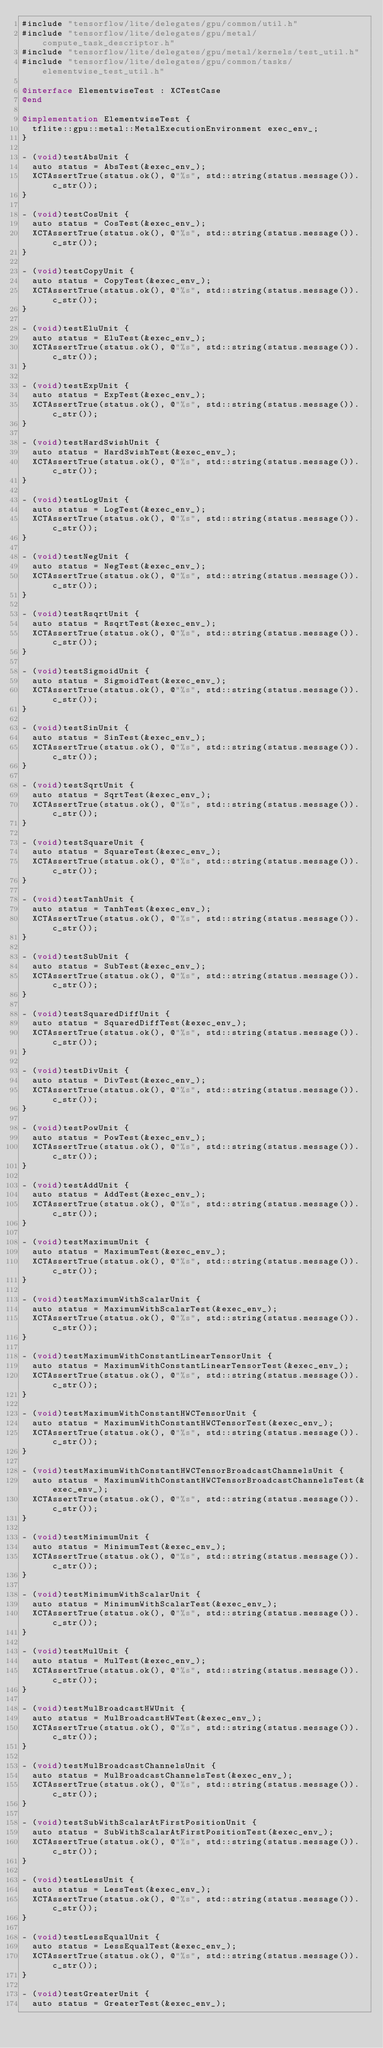<code> <loc_0><loc_0><loc_500><loc_500><_ObjectiveC_>#include "tensorflow/lite/delegates/gpu/common/util.h"
#include "tensorflow/lite/delegates/gpu/metal/compute_task_descriptor.h"
#include "tensorflow/lite/delegates/gpu/metal/kernels/test_util.h"
#include "tensorflow/lite/delegates/gpu/common/tasks/elementwise_test_util.h"

@interface ElementwiseTest : XCTestCase
@end

@implementation ElementwiseTest {
  tflite::gpu::metal::MetalExecutionEnvironment exec_env_;
}

- (void)testAbsUnit {
  auto status = AbsTest(&exec_env_);
  XCTAssertTrue(status.ok(), @"%s", std::string(status.message()).c_str());
}

- (void)testCosUnit {
  auto status = CosTest(&exec_env_);
  XCTAssertTrue(status.ok(), @"%s", std::string(status.message()).c_str());
}

- (void)testCopyUnit {
  auto status = CopyTest(&exec_env_);
  XCTAssertTrue(status.ok(), @"%s", std::string(status.message()).c_str());
}

- (void)testEluUnit {
  auto status = EluTest(&exec_env_);
  XCTAssertTrue(status.ok(), @"%s", std::string(status.message()).c_str());
}

- (void)testExpUnit {
  auto status = ExpTest(&exec_env_);
  XCTAssertTrue(status.ok(), @"%s", std::string(status.message()).c_str());
}

- (void)testHardSwishUnit {
  auto status = HardSwishTest(&exec_env_);
  XCTAssertTrue(status.ok(), @"%s", std::string(status.message()).c_str());
}

- (void)testLogUnit {
  auto status = LogTest(&exec_env_);
  XCTAssertTrue(status.ok(), @"%s", std::string(status.message()).c_str());
}

- (void)testNegUnit {
  auto status = NegTest(&exec_env_);
  XCTAssertTrue(status.ok(), @"%s", std::string(status.message()).c_str());
}

- (void)testRsqrtUnit {
  auto status = RsqrtTest(&exec_env_);
  XCTAssertTrue(status.ok(), @"%s", std::string(status.message()).c_str());
}

- (void)testSigmoidUnit {
  auto status = SigmoidTest(&exec_env_);
  XCTAssertTrue(status.ok(), @"%s", std::string(status.message()).c_str());
}

- (void)testSinUnit {
  auto status = SinTest(&exec_env_);
  XCTAssertTrue(status.ok(), @"%s", std::string(status.message()).c_str());
}

- (void)testSqrtUnit {
  auto status = SqrtTest(&exec_env_);
  XCTAssertTrue(status.ok(), @"%s", std::string(status.message()).c_str());
}

- (void)testSquareUnit {
  auto status = SquareTest(&exec_env_);
  XCTAssertTrue(status.ok(), @"%s", std::string(status.message()).c_str());
}

- (void)testTanhUnit {
  auto status = TanhTest(&exec_env_);
  XCTAssertTrue(status.ok(), @"%s", std::string(status.message()).c_str());
}

- (void)testSubUnit {
  auto status = SubTest(&exec_env_);
  XCTAssertTrue(status.ok(), @"%s", std::string(status.message()).c_str());
}

- (void)testSquaredDiffUnit {
  auto status = SquaredDiffTest(&exec_env_);
  XCTAssertTrue(status.ok(), @"%s", std::string(status.message()).c_str());
}

- (void)testDivUnit {
  auto status = DivTest(&exec_env_);
  XCTAssertTrue(status.ok(), @"%s", std::string(status.message()).c_str());
}

- (void)testPowUnit {
  auto status = PowTest(&exec_env_);
  XCTAssertTrue(status.ok(), @"%s", std::string(status.message()).c_str());
}

- (void)testAddUnit {
  auto status = AddTest(&exec_env_);
  XCTAssertTrue(status.ok(), @"%s", std::string(status.message()).c_str());
}

- (void)testMaximumUnit {
  auto status = MaximumTest(&exec_env_);
  XCTAssertTrue(status.ok(), @"%s", std::string(status.message()).c_str());
}

- (void)testMaximumWithScalarUnit {
  auto status = MaximumWithScalarTest(&exec_env_);
  XCTAssertTrue(status.ok(), @"%s", std::string(status.message()).c_str());
}

- (void)testMaximumWithConstantLinearTensorUnit {
  auto status = MaximumWithConstantLinearTensorTest(&exec_env_);
  XCTAssertTrue(status.ok(), @"%s", std::string(status.message()).c_str());
}

- (void)testMaximumWithConstantHWCTensorUnit {
  auto status = MaximumWithConstantHWCTensorTest(&exec_env_);
  XCTAssertTrue(status.ok(), @"%s", std::string(status.message()).c_str());
}

- (void)testMaximumWithConstantHWCTensorBroadcastChannelsUnit {
  auto status = MaximumWithConstantHWCTensorBroadcastChannelsTest(&exec_env_);
  XCTAssertTrue(status.ok(), @"%s", std::string(status.message()).c_str());
}

- (void)testMinimumUnit {
  auto status = MinimumTest(&exec_env_);
  XCTAssertTrue(status.ok(), @"%s", std::string(status.message()).c_str());
}

- (void)testMinimumWithScalarUnit {
  auto status = MinimumWithScalarTest(&exec_env_);
  XCTAssertTrue(status.ok(), @"%s", std::string(status.message()).c_str());
}

- (void)testMulUnit {
  auto status = MulTest(&exec_env_);
  XCTAssertTrue(status.ok(), @"%s", std::string(status.message()).c_str());
}

- (void)testMulBroadcastHWUnit {
  auto status = MulBroadcastHWTest(&exec_env_);
  XCTAssertTrue(status.ok(), @"%s", std::string(status.message()).c_str());
}

- (void)testMulBroadcastChannelsUnit {
  auto status = MulBroadcastChannelsTest(&exec_env_);
  XCTAssertTrue(status.ok(), @"%s", std::string(status.message()).c_str());
}

- (void)testSubWithScalarAtFirstPositionUnit {
  auto status = SubWithScalarAtFirstPositionTest(&exec_env_);
  XCTAssertTrue(status.ok(), @"%s", std::string(status.message()).c_str());
}

- (void)testLessUnit {
  auto status = LessTest(&exec_env_);
  XCTAssertTrue(status.ok(), @"%s", std::string(status.message()).c_str());
}

- (void)testLessEqualUnit {
  auto status = LessEqualTest(&exec_env_);
  XCTAssertTrue(status.ok(), @"%s", std::string(status.message()).c_str());
}

- (void)testGreaterUnit {
  auto status = GreaterTest(&exec_env_);</code> 